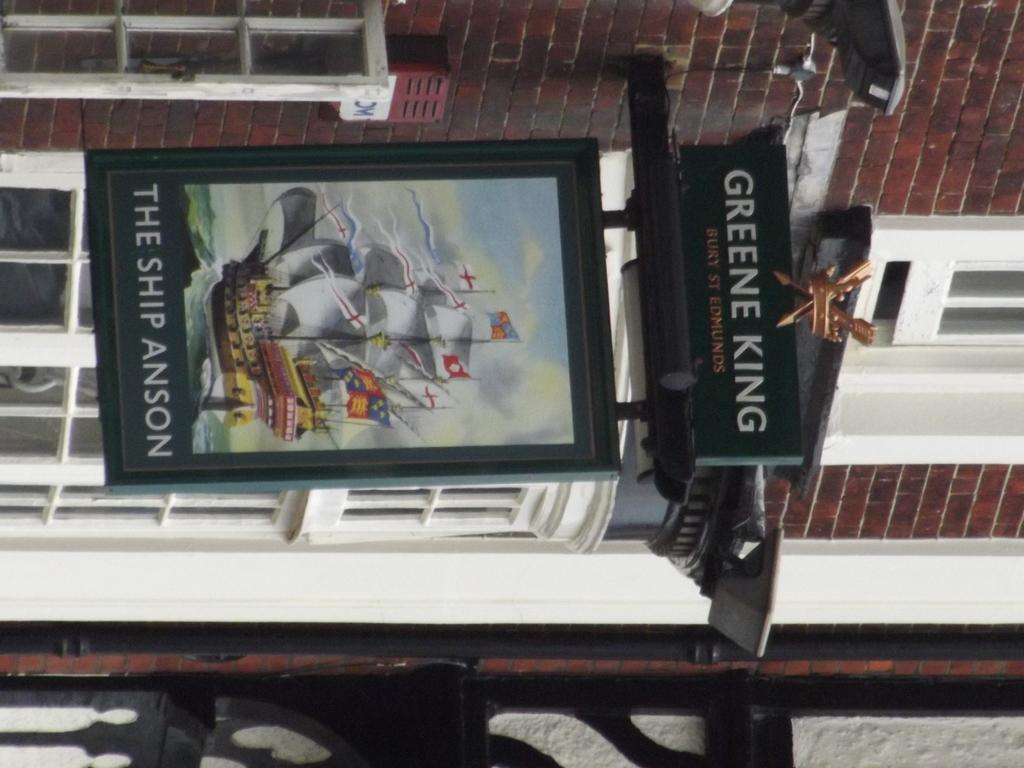<image>
Offer a succinct explanation of the picture presented. A sign hanging off a brick wall says the ship anson on it. 